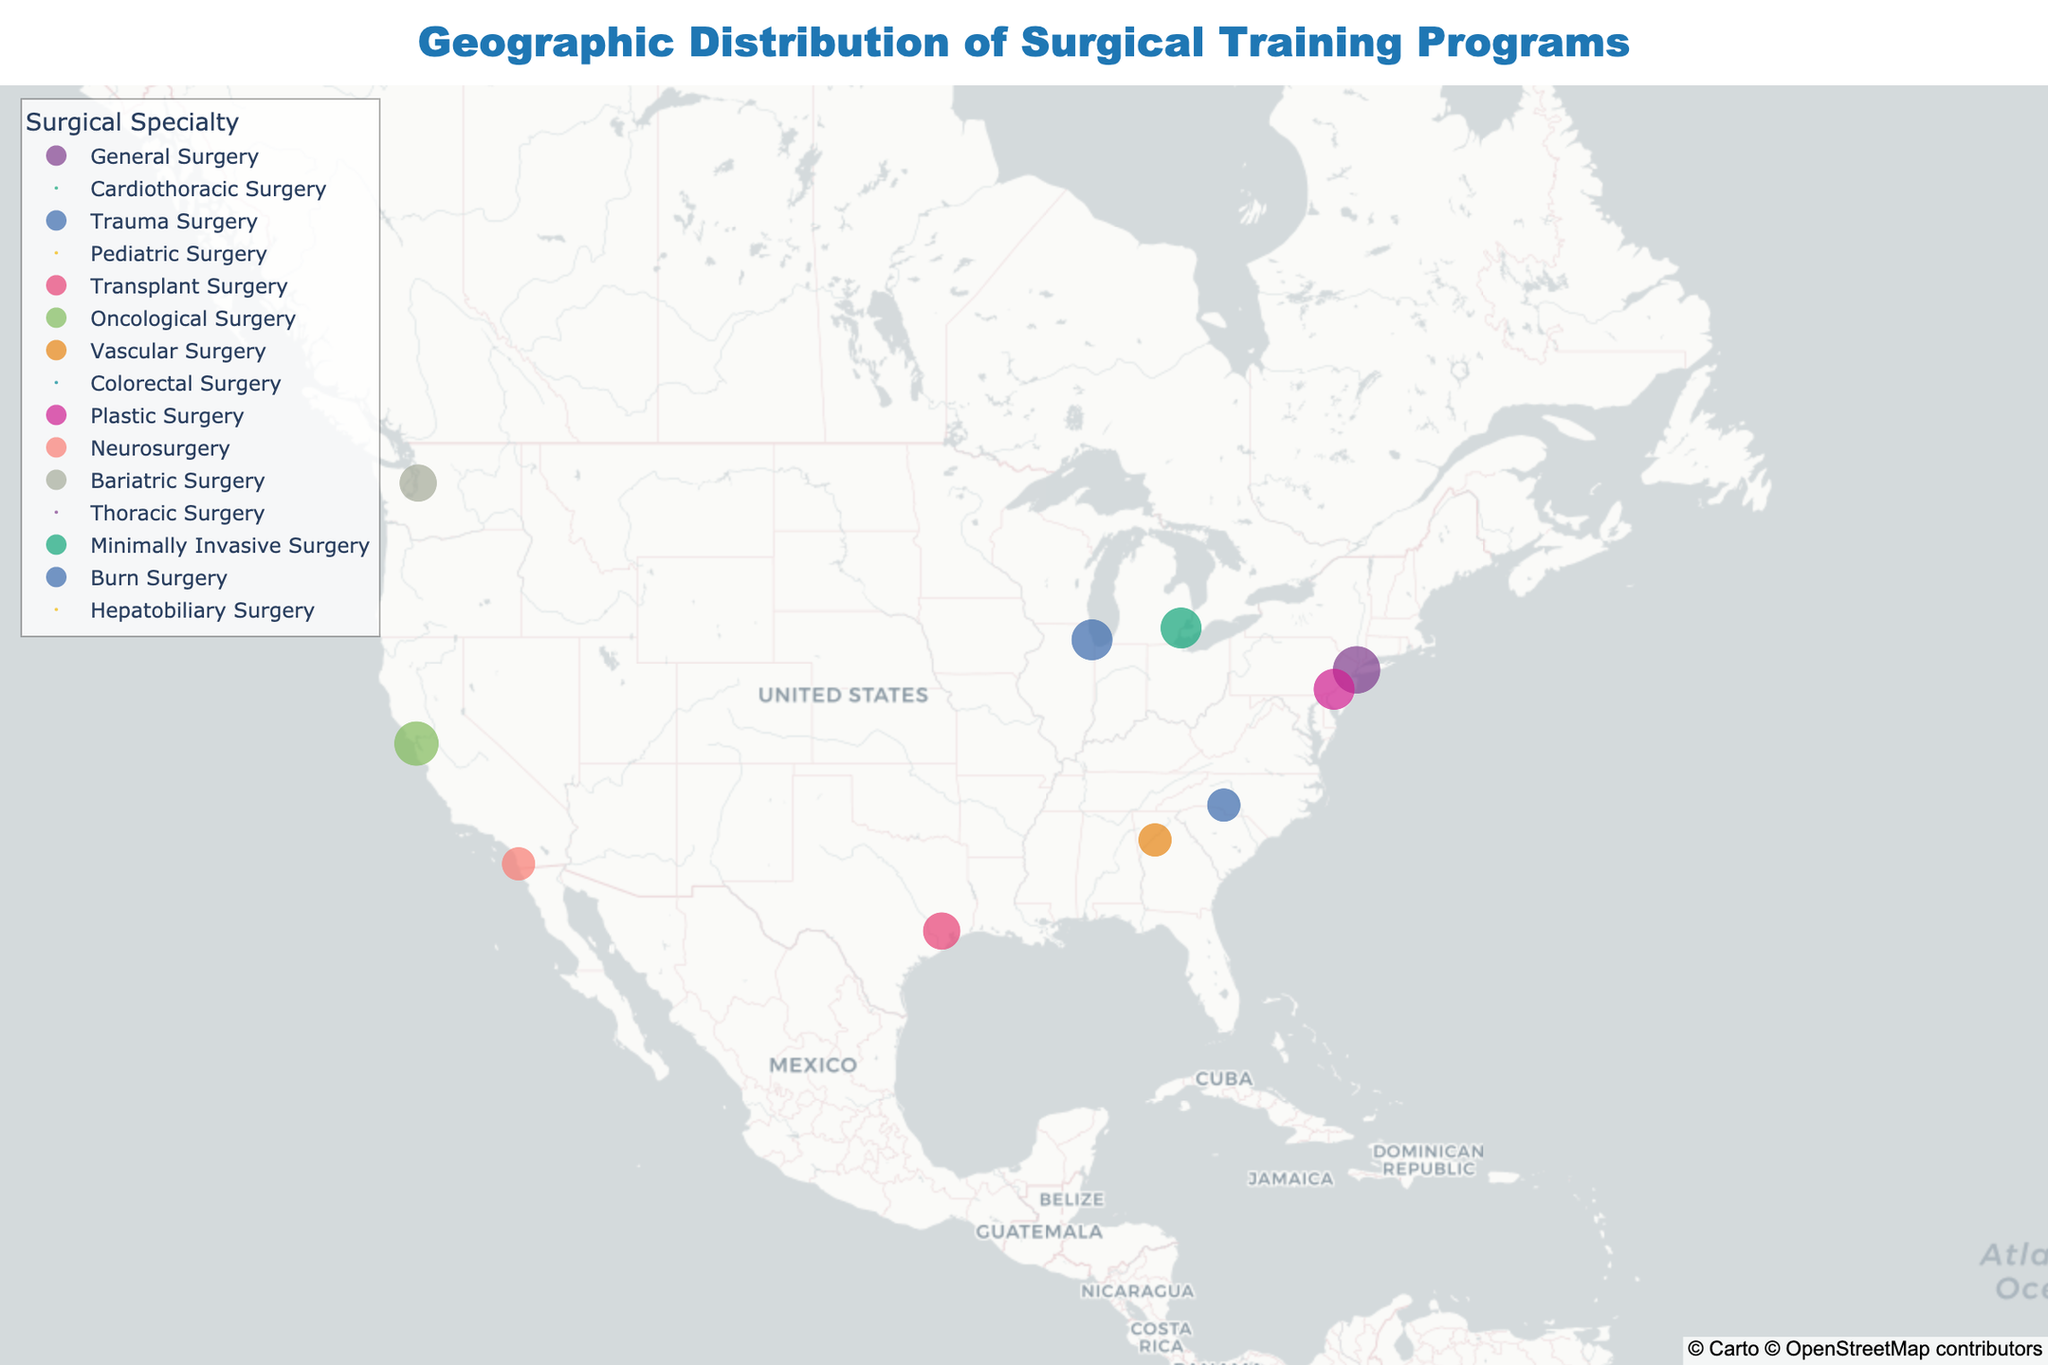How many residency spots are available at NYU Langone Health? The figure displays a scatter plot, each point representing a specific institution. By hovering over NYU Langone Health, you can see that it offers 8 residency spots.
Answer: 8 Which institution has the most fellowship spots and how many? By hovering over each point, you can see the number of fellowship spots for each institution. Cedars-Sinai Medical Center has the most fellowship spots, with 4.
Answer: Cedars-Sinai Medical Center with 4 Which specialty is represented by Texas Medical Center, and how many fellowship spots does it offer? By locating and hovering over the point representing Texas Medical Center, you can see that it specializes in transplant surgery and offers 3 fellowship spots.
Answer: Transplant Surgery with 3 fellowship spots Compare the number of residency spots between UCSF Medical Center and Emory University Hospital. Which has more? By hovering over the points for UCSF Medical Center and Emory University Hospital, UCSF Medical Center offers 7 residency spots while Emory University Hospital offers 4. Therefore, UCSF Medical Center has more.
Answer: UCSF Medical Center What's the total number of residency spots for institutions specializing in some form of surgery starting with the letter "P"? Identify the specialties starting with "P" (Pediatric, Plastic). Massachusetts General Hospital (Pediatric Surgery, 0 residency spots) and Hospital of the University of Pennsylvania (Plastic Surgery, 6 residency spots). Sum them up: 0 + 6 = 6.
Answer: 6 Which region of the United States has the highest concentration of surgical training programs depicted, East or West, and how did you determine this? By visually examining the distribution of points on the map, the East (including cities like New York, Philadelphia, Washington) has a higher concentration of surgical training programs compared to the West.
Answer: East Identify an institution that offers training in Vascular Surgery and state its location. Hover over the corresponding points to identify Emory University Hospital, which specializes in Vascular Surgery, located in Atlanta, Georgia (Latitude 33.7490, Longitude -84.3880).
Answer: Emory University Hospital, Atlanta How does the number of fellowship spots at Johns Hopkins Hospital compare to MedStar Washington Hospital Center? By hovering over the points for each institution, Johns Hopkins Hospital offers 3 fellowship spots, while MedStar Washington Hospital Center also offers 3. Therefore, both have the same number of fellowship spots.
Answer: Same, 3 What specialty is associated with the institution located at the northernmost point on the map, and how many residency spots are offered there? The northernmost point belongs to UW Medicine (Seattle, Washington). Hovering over this point indicates it specializes in Bariatric Surgery with 5 residency spots.
Answer: Bariatric Surgery with 5 residency spots If you were to average the number of residency spots across all institutions presented, what would the average be? Sum the total residency spots: 8 (NYU) + 0 (Cedars-Sinai) + 6 (Northwestern) + 0 (Massachusetts) + 5 (Texas) + 7 (UCSF) + 4 (Emory) + 0 (MedStar) + 6 (Pennsylvania) + 4 (UC San Diego) + 5 (UW) + 0 (Johns Hopkins) + 6 (Henry Ford) + 4 (Atrium) + 0 (Cleveland). Total = 55. Divide by the number of institutions (15). 55 / 15 ≈ 3.7.
Answer: 3.7 